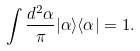<formula> <loc_0><loc_0><loc_500><loc_500>\int \frac { d ^ { 2 } \alpha } { \pi } | \alpha \rangle \langle \alpha | = 1 .</formula> 